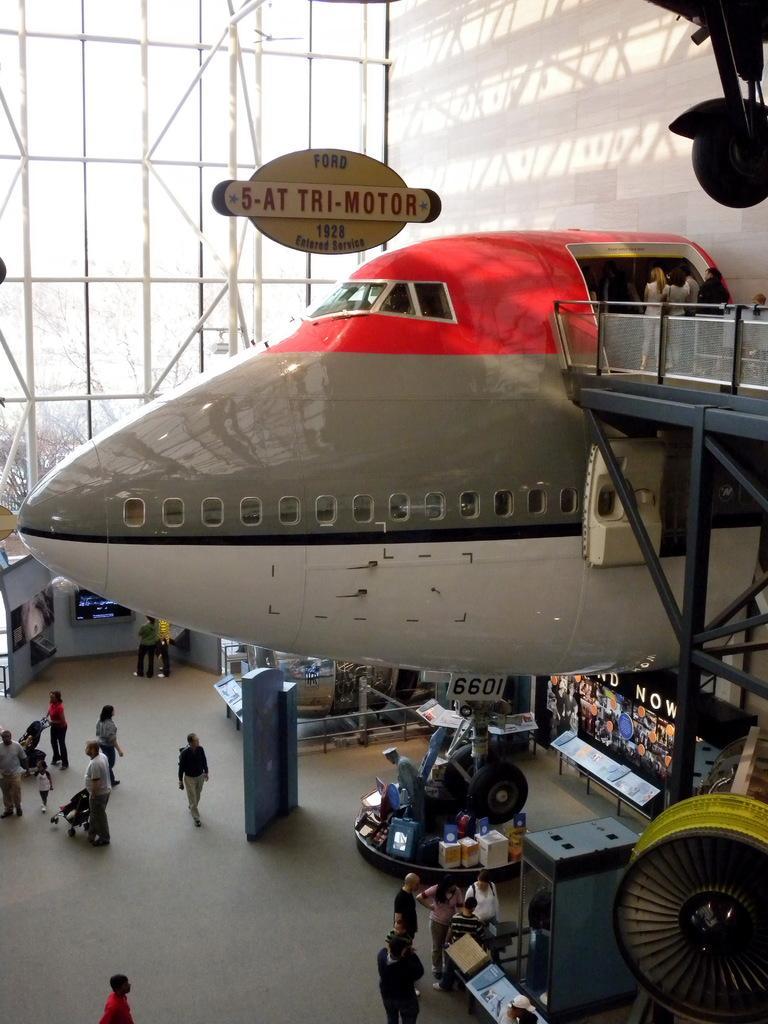In one or two sentences, can you explain what this image depicts? The image is clicked in a building. In the center of the picture there is an airplane shaped building. In the background there is a glass window and poles, outside the window we can see trees. At the bottom there are stores and people walking. On the right there is a wheel. 